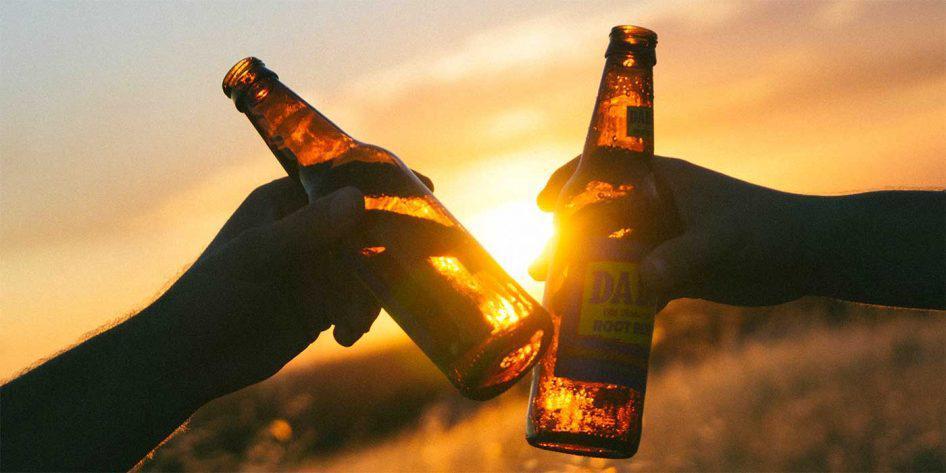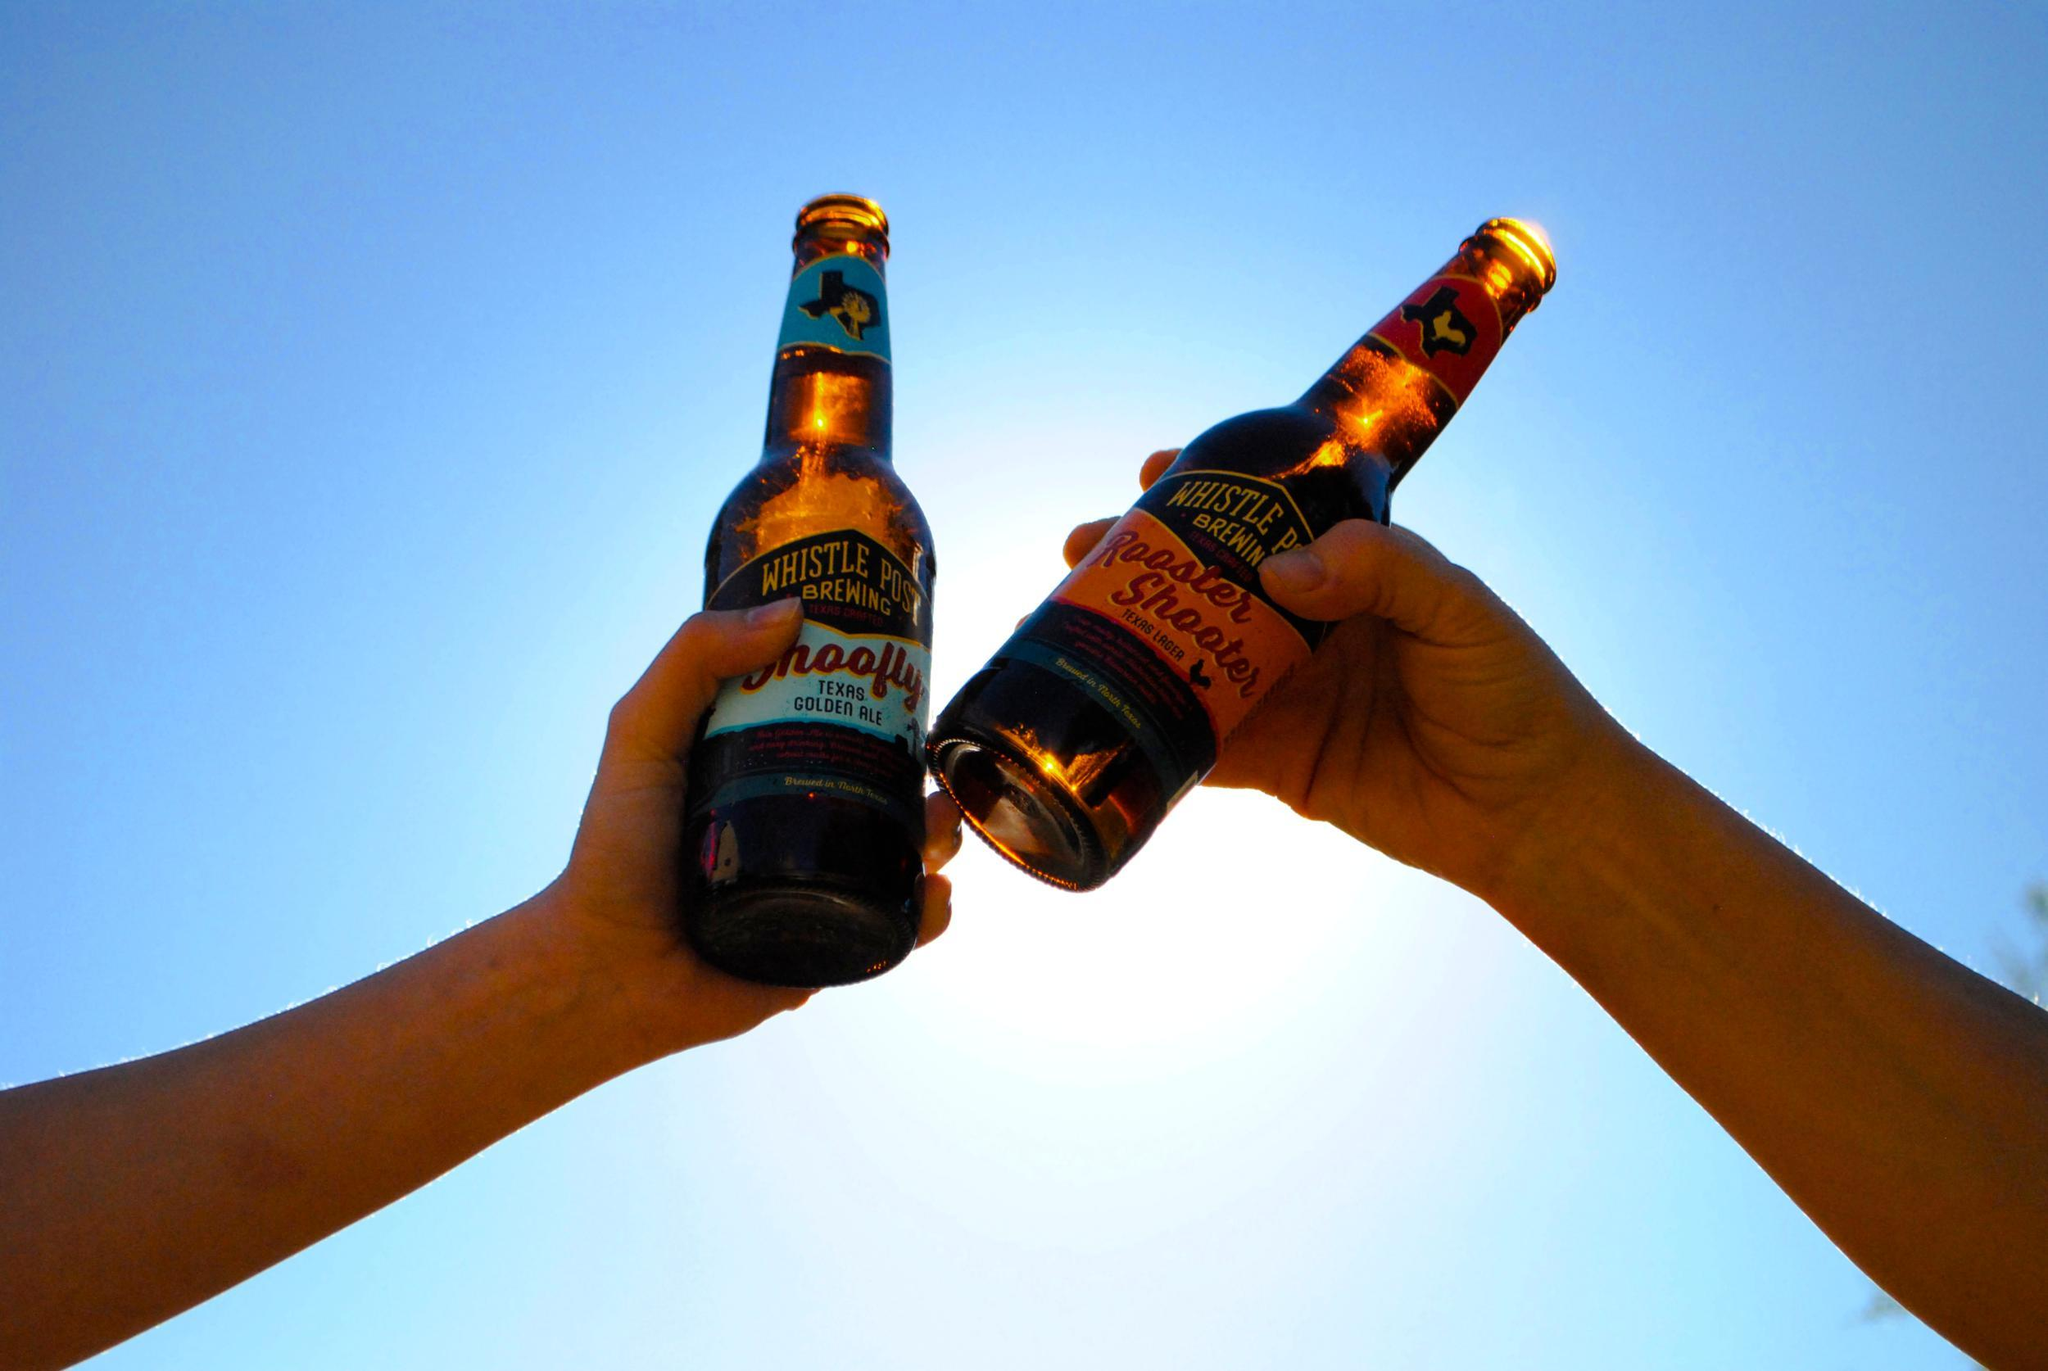The first image is the image on the left, the second image is the image on the right. For the images shown, is this caption "There are exactly four bottles being toasted, two in each image." true? Answer yes or no. Yes. The first image is the image on the left, the second image is the image on the right. Considering the images on both sides, is "Each image includes hands holding glass bottles that clink together at the bases of the bottles." valid? Answer yes or no. Yes. 